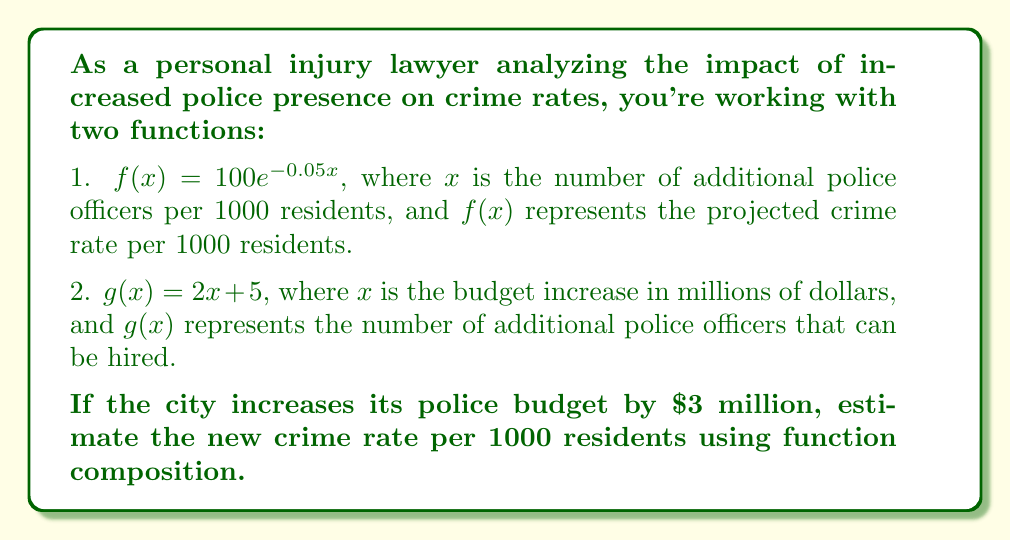Provide a solution to this math problem. To solve this problem, we need to use function composition. We'll follow these steps:

1. Determine the number of additional police officers hired with a $3 million budget increase:
   $g(3) = 2(3) + 5 = 11$ additional officers

2. Use this result as input for function $f$:
   $f(g(3)) = f(11)$

3. Calculate the projected crime rate:
   $f(11) = 100e^{-0.05(11)}$

4. Evaluate the exponential function:
   $f(11) = 100e^{-0.55}$
   $f(11) = 100 \cdot 0.5769$
   $f(11) = 57.69$

The function composition $(f \circ g)(3)$ gives us the estimated crime rate after a $3 million budget increase.

$(f \circ g)(3) = f(g(3)) = f(11) = 57.69$ crimes per 1000 residents
Answer: The estimated crime rate after a $3 million budget increase is approximately 57.69 crimes per 1000 residents. 